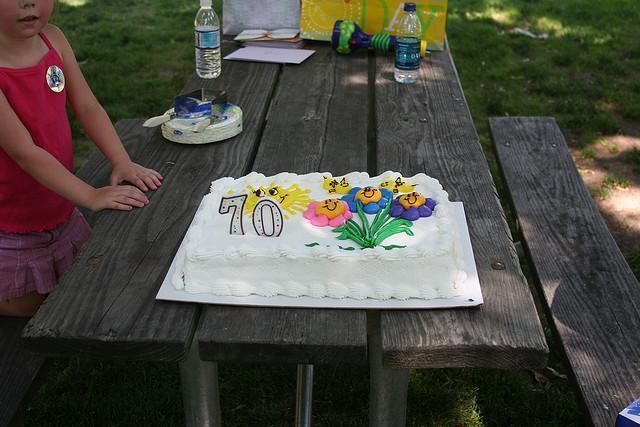How many benches are visible?
Give a very brief answer. 2. 